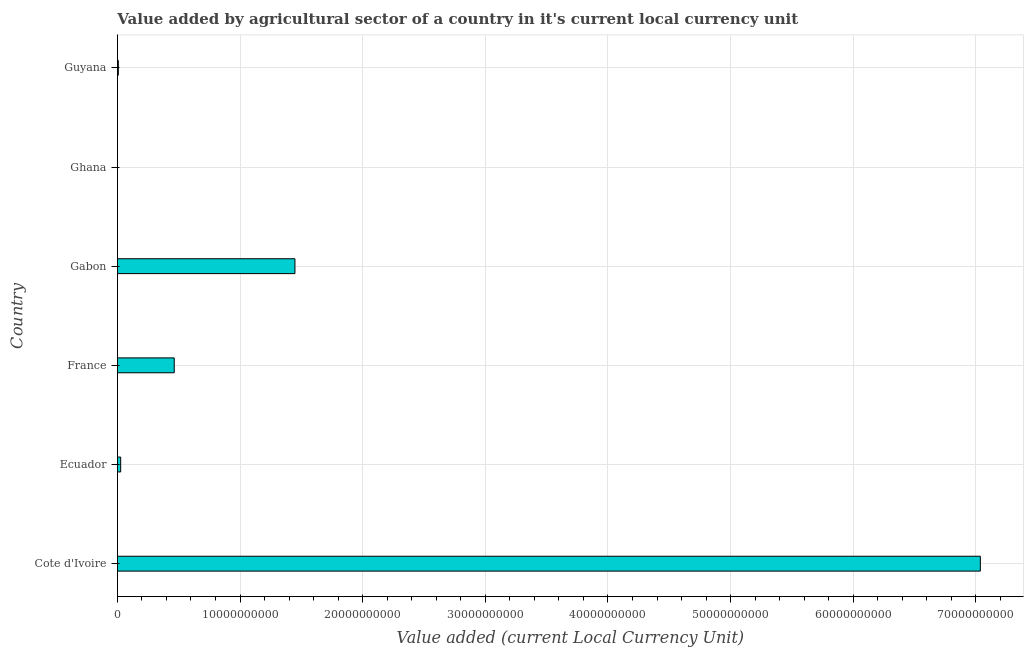Does the graph contain grids?
Your answer should be compact. Yes. What is the title of the graph?
Offer a terse response. Value added by agricultural sector of a country in it's current local currency unit. What is the label or title of the X-axis?
Your response must be concise. Value added (current Local Currency Unit). What is the label or title of the Y-axis?
Keep it short and to the point. Country. What is the value added by agriculture sector in Guyana?
Give a very brief answer. 7.60e+07. Across all countries, what is the maximum value added by agriculture sector?
Ensure brevity in your answer.  7.04e+1. Across all countries, what is the minimum value added by agriculture sector?
Provide a succinct answer. 3.29e+04. In which country was the value added by agriculture sector maximum?
Your response must be concise. Cote d'Ivoire. What is the sum of the value added by agriculture sector?
Offer a very short reply. 8.98e+1. What is the difference between the value added by agriculture sector in Ecuador and Guyana?
Provide a short and direct response. 1.90e+08. What is the average value added by agriculture sector per country?
Keep it short and to the point. 1.50e+1. What is the median value added by agriculture sector?
Provide a short and direct response. 2.45e+09. What is the ratio of the value added by agriculture sector in Cote d'Ivoire to that in Gabon?
Provide a short and direct response. 4.86. Is the difference between the value added by agriculture sector in Cote d'Ivoire and France greater than the difference between any two countries?
Offer a terse response. No. What is the difference between the highest and the second highest value added by agriculture sector?
Offer a very short reply. 5.59e+1. What is the difference between the highest and the lowest value added by agriculture sector?
Your answer should be very brief. 7.04e+1. In how many countries, is the value added by agriculture sector greater than the average value added by agriculture sector taken over all countries?
Provide a short and direct response. 1. How many bars are there?
Provide a short and direct response. 6. What is the Value added (current Local Currency Unit) in Cote d'Ivoire?
Offer a very short reply. 7.04e+1. What is the Value added (current Local Currency Unit) in Ecuador?
Give a very brief answer. 2.66e+08. What is the Value added (current Local Currency Unit) in France?
Offer a terse response. 4.63e+09. What is the Value added (current Local Currency Unit) in Gabon?
Give a very brief answer. 1.45e+1. What is the Value added (current Local Currency Unit) in Ghana?
Give a very brief answer. 3.29e+04. What is the Value added (current Local Currency Unit) of Guyana?
Give a very brief answer. 7.60e+07. What is the difference between the Value added (current Local Currency Unit) in Cote d'Ivoire and Ecuador?
Offer a terse response. 7.01e+1. What is the difference between the Value added (current Local Currency Unit) in Cote d'Ivoire and France?
Give a very brief answer. 6.57e+1. What is the difference between the Value added (current Local Currency Unit) in Cote d'Ivoire and Gabon?
Ensure brevity in your answer.  5.59e+1. What is the difference between the Value added (current Local Currency Unit) in Cote d'Ivoire and Ghana?
Ensure brevity in your answer.  7.04e+1. What is the difference between the Value added (current Local Currency Unit) in Cote d'Ivoire and Guyana?
Offer a terse response. 7.03e+1. What is the difference between the Value added (current Local Currency Unit) in Ecuador and France?
Your answer should be very brief. -4.37e+09. What is the difference between the Value added (current Local Currency Unit) in Ecuador and Gabon?
Provide a succinct answer. -1.42e+1. What is the difference between the Value added (current Local Currency Unit) in Ecuador and Ghana?
Your response must be concise. 2.66e+08. What is the difference between the Value added (current Local Currency Unit) in Ecuador and Guyana?
Your response must be concise. 1.90e+08. What is the difference between the Value added (current Local Currency Unit) in France and Gabon?
Offer a terse response. -9.84e+09. What is the difference between the Value added (current Local Currency Unit) in France and Ghana?
Ensure brevity in your answer.  4.63e+09. What is the difference between the Value added (current Local Currency Unit) in France and Guyana?
Keep it short and to the point. 4.56e+09. What is the difference between the Value added (current Local Currency Unit) in Gabon and Ghana?
Offer a terse response. 1.45e+1. What is the difference between the Value added (current Local Currency Unit) in Gabon and Guyana?
Your answer should be compact. 1.44e+1. What is the difference between the Value added (current Local Currency Unit) in Ghana and Guyana?
Make the answer very short. -7.60e+07. What is the ratio of the Value added (current Local Currency Unit) in Cote d'Ivoire to that in Ecuador?
Offer a very short reply. 264.36. What is the ratio of the Value added (current Local Currency Unit) in Cote d'Ivoire to that in France?
Your answer should be very brief. 15.19. What is the ratio of the Value added (current Local Currency Unit) in Cote d'Ivoire to that in Gabon?
Offer a terse response. 4.86. What is the ratio of the Value added (current Local Currency Unit) in Cote d'Ivoire to that in Ghana?
Keep it short and to the point. 2.14e+06. What is the ratio of the Value added (current Local Currency Unit) in Cote d'Ivoire to that in Guyana?
Give a very brief answer. 925.88. What is the ratio of the Value added (current Local Currency Unit) in Ecuador to that in France?
Your response must be concise. 0.06. What is the ratio of the Value added (current Local Currency Unit) in Ecuador to that in Gabon?
Provide a succinct answer. 0.02. What is the ratio of the Value added (current Local Currency Unit) in Ecuador to that in Ghana?
Your answer should be compact. 8090.72. What is the ratio of the Value added (current Local Currency Unit) in Ecuador to that in Guyana?
Your answer should be compact. 3.5. What is the ratio of the Value added (current Local Currency Unit) in France to that in Gabon?
Your answer should be compact. 0.32. What is the ratio of the Value added (current Local Currency Unit) in France to that in Ghana?
Your answer should be very brief. 1.41e+05. What is the ratio of the Value added (current Local Currency Unit) in France to that in Guyana?
Offer a very short reply. 60.97. What is the ratio of the Value added (current Local Currency Unit) in Gabon to that in Ghana?
Give a very brief answer. 4.40e+05. What is the ratio of the Value added (current Local Currency Unit) in Gabon to that in Guyana?
Ensure brevity in your answer.  190.49. 